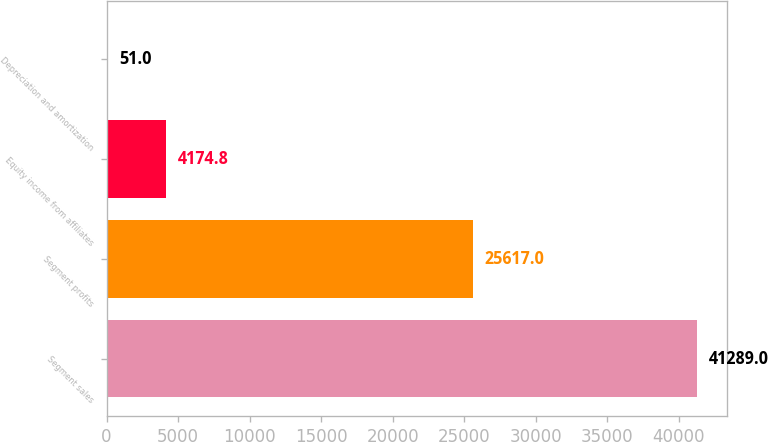Convert chart to OTSL. <chart><loc_0><loc_0><loc_500><loc_500><bar_chart><fcel>Segment sales<fcel>Segment profits<fcel>Equity income from affiliates<fcel>Depreciation and amortization<nl><fcel>41289<fcel>25617<fcel>4174.8<fcel>51<nl></chart> 